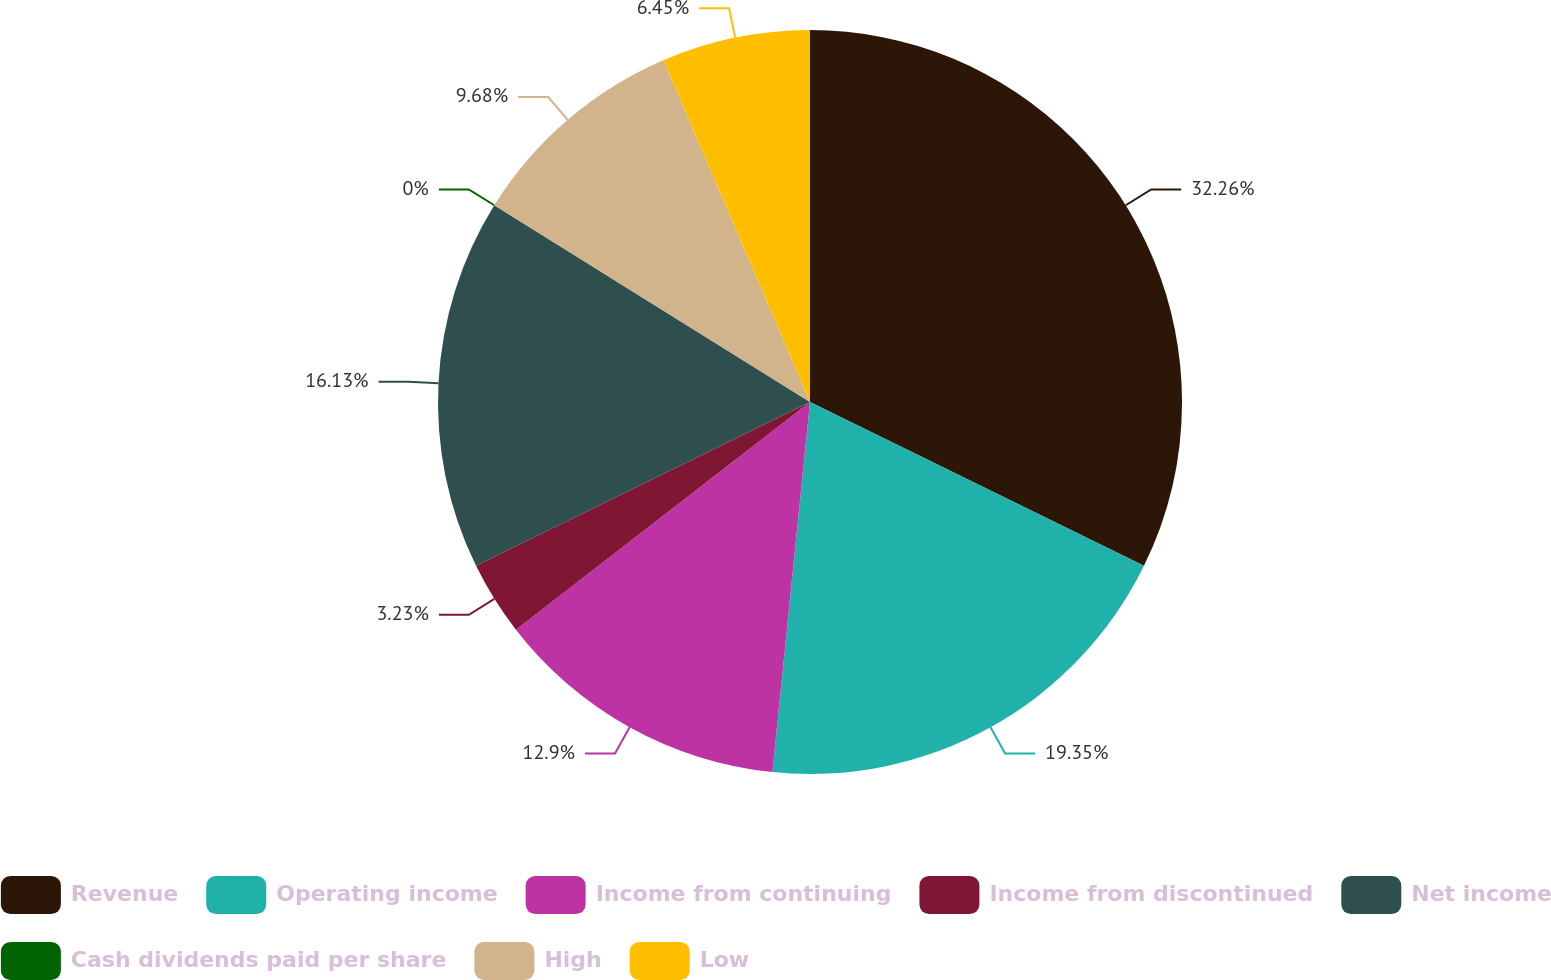Convert chart. <chart><loc_0><loc_0><loc_500><loc_500><pie_chart><fcel>Revenue<fcel>Operating income<fcel>Income from continuing<fcel>Income from discontinued<fcel>Net income<fcel>Cash dividends paid per share<fcel>High<fcel>Low<nl><fcel>32.26%<fcel>19.35%<fcel>12.9%<fcel>3.23%<fcel>16.13%<fcel>0.0%<fcel>9.68%<fcel>6.45%<nl></chart> 